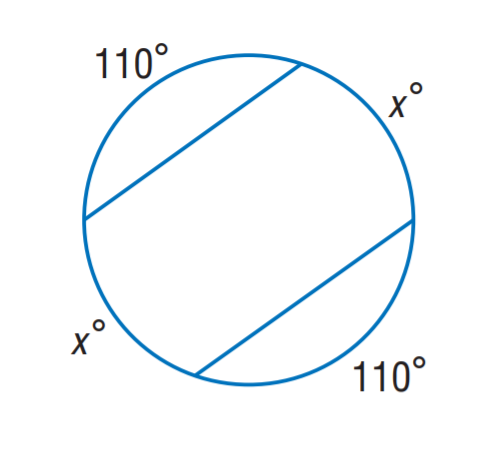Answer the mathemtical geometry problem and directly provide the correct option letter.
Question: Find x.
Choices: A: 35 B: 55 C: 70 D: 110 C 